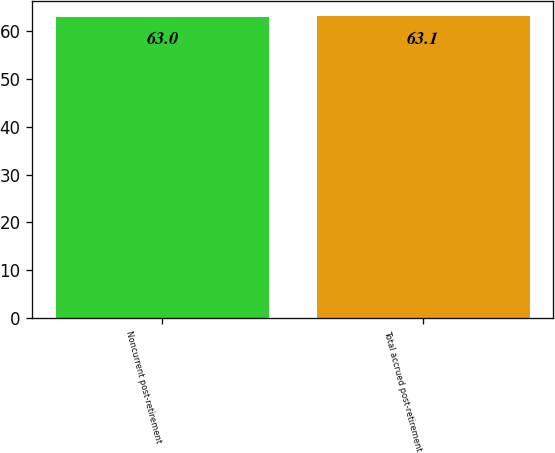<chart> <loc_0><loc_0><loc_500><loc_500><bar_chart><fcel>Noncurrent post-retirement<fcel>Total accrued post-retirement<nl><fcel>63<fcel>63.1<nl></chart> 